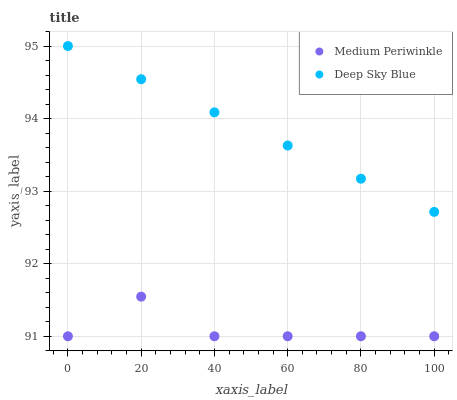Does Medium Periwinkle have the minimum area under the curve?
Answer yes or no. Yes. Does Deep Sky Blue have the maximum area under the curve?
Answer yes or no. Yes. Does Deep Sky Blue have the minimum area under the curve?
Answer yes or no. No. Is Deep Sky Blue the smoothest?
Answer yes or no. Yes. Is Medium Periwinkle the roughest?
Answer yes or no. Yes. Is Deep Sky Blue the roughest?
Answer yes or no. No. Does Medium Periwinkle have the lowest value?
Answer yes or no. Yes. Does Deep Sky Blue have the lowest value?
Answer yes or no. No. Does Deep Sky Blue have the highest value?
Answer yes or no. Yes. Is Medium Periwinkle less than Deep Sky Blue?
Answer yes or no. Yes. Is Deep Sky Blue greater than Medium Periwinkle?
Answer yes or no. Yes. Does Medium Periwinkle intersect Deep Sky Blue?
Answer yes or no. No. 